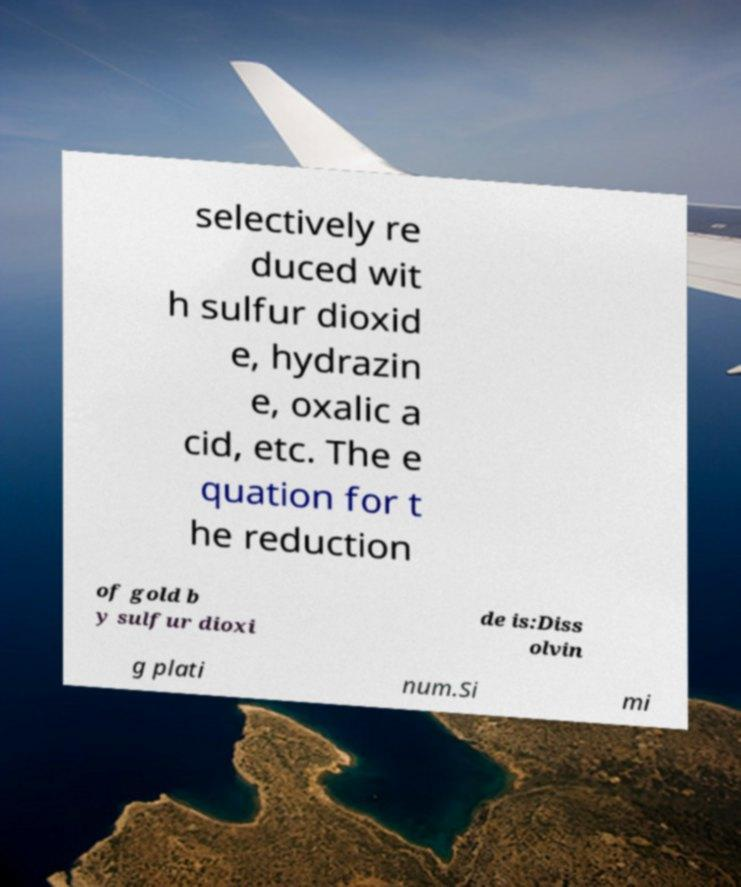There's text embedded in this image that I need extracted. Can you transcribe it verbatim? selectively re duced wit h sulfur dioxid e, hydrazin e, oxalic a cid, etc. The e quation for t he reduction of gold b y sulfur dioxi de is:Diss olvin g plati num.Si mi 